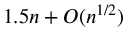Convert formula to latex. <formula><loc_0><loc_0><loc_500><loc_500>1 . 5 n + O ( n ^ { 1 / 2 } )</formula> 